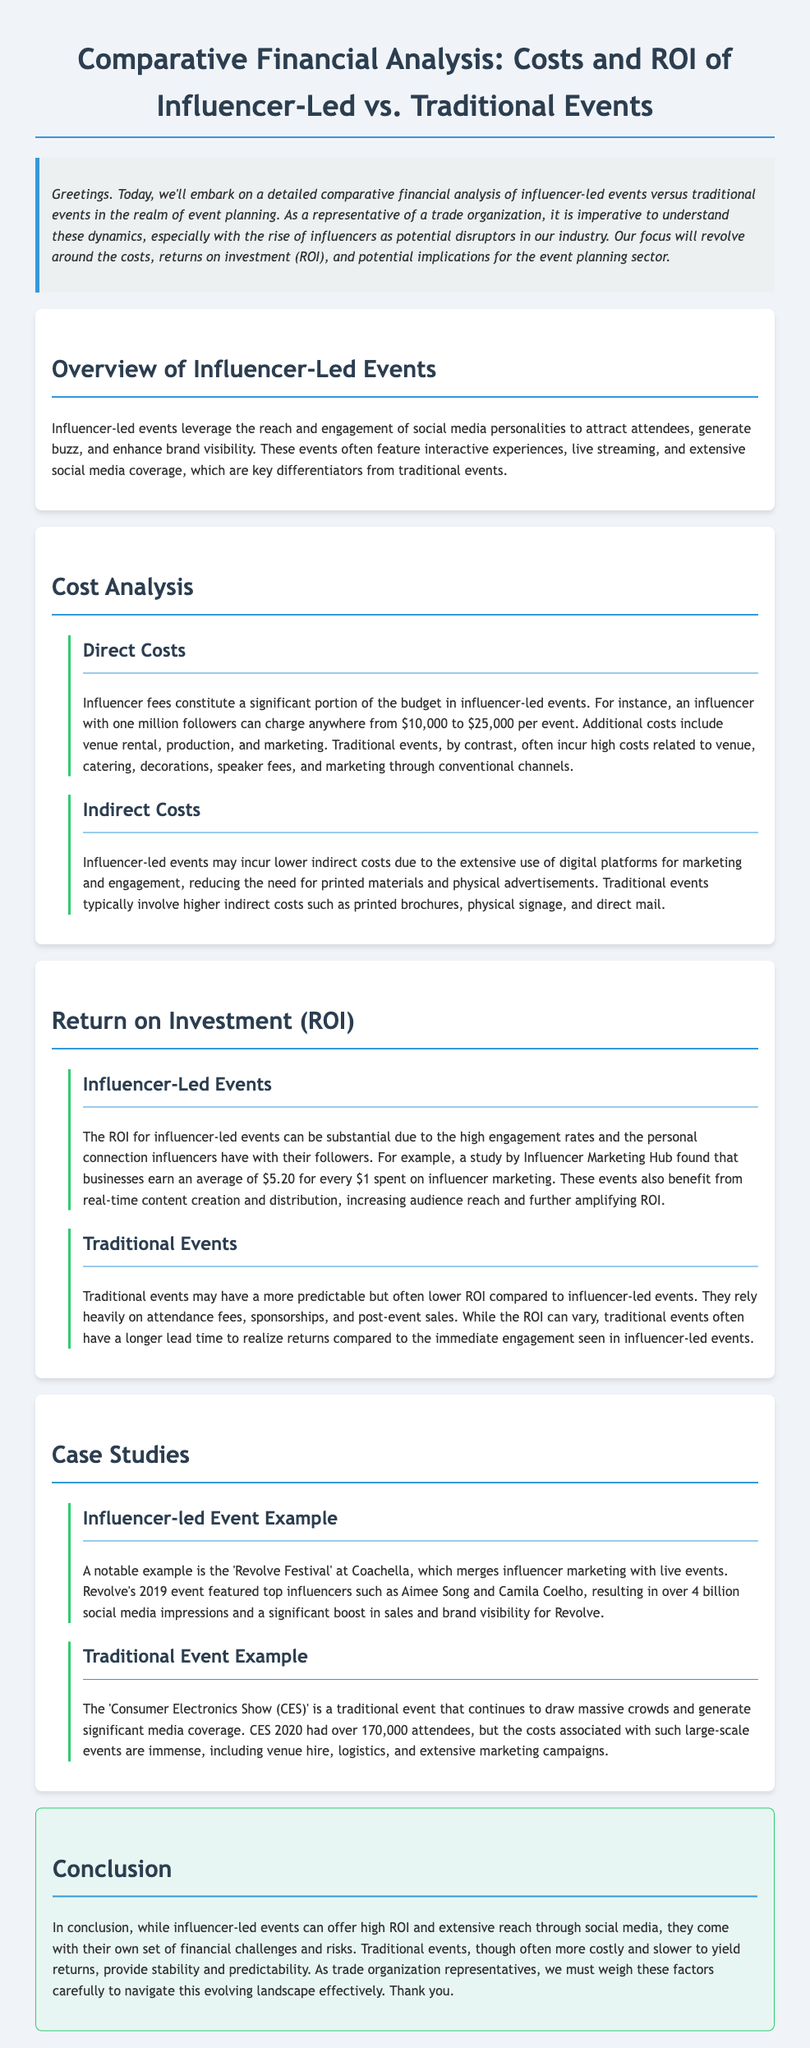What is the average revenue earned for every dollar spent on influencer marketing? The document states that businesses earn an average of $5.20 for every $1 spent on influencer marketing.
Answer: $5.20 What is a key differentiator for influencer-led events? Influencer-led events often feature interactive experiences, live streaming, and extensive social media coverage, which are key differentiators from traditional events.
Answer: Interactive experiences What was a notable influencer-led event mentioned in the document? The document provides the example of 'Revolve Festival' at Coachella as a prominent influencer-led event.
Answer: Revolve Festival What are the main direct costs for influencer-led events? Influencer fees constitute a significant portion of the budget in influencer-led events.
Answer: Influencer fees How many attendees did CES 2020 have? The document mentions that CES 2020 had over 170,000 attendees.
Answer: 170,000 What type of content creation benefit do influencer-led events have? The document states that influencer-led events benefit from real-time content creation and distribution, which increases audience reach.
Answer: Real-time content creation What does the ROI for traditional events rely heavily on? Traditional events rely heavily on attendance fees, sponsorships, and post-event sales.
Answer: Attendance fees What is a disadvantage of traditional events compared to influencer-led events? The document notes that traditional events often have a more predictable but lower ROI compared to influencer-led events.
Answer: Lower ROI What is a significant indirect cost aspect for traditional events? Traditional events typically involve higher indirect costs such as printed brochures, physical signage, and direct mail.
Answer: Printed brochures 